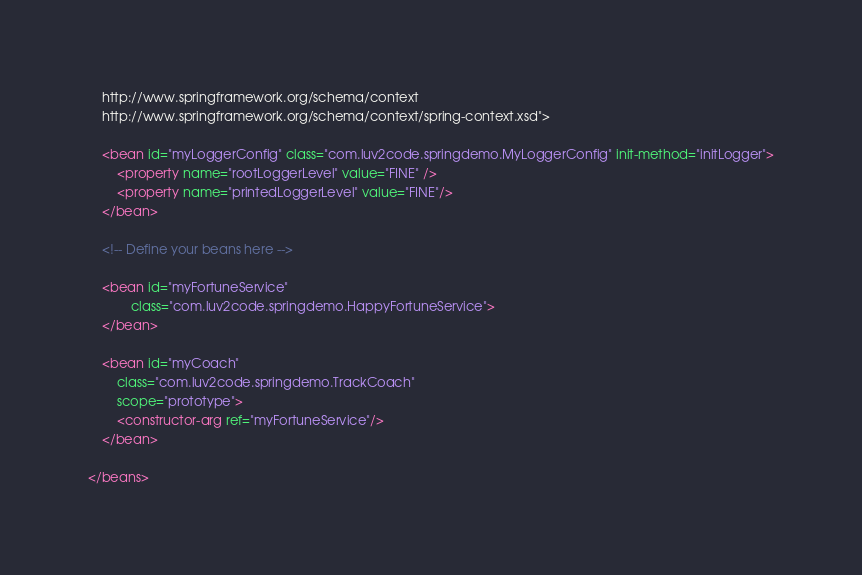<code> <loc_0><loc_0><loc_500><loc_500><_XML_>    http://www.springframework.org/schema/context
    http://www.springframework.org/schema/context/spring-context.xsd">

    <bean id="myLoggerConfig" class="com.luv2code.springdemo.MyLoggerConfig" init-method="initLogger">
    	<property name="rootLoggerLevel" value="FINE" />
    	<property name="printedLoggerLevel" value="FINE"/>
    </bean>
	
    <!-- Define your beans here -->
        
    <bean id="myFortuneService"
    		class="com.luv2code.springdemo.HappyFortuneService">
  	</bean>    

 	<bean id="myCoach"
 		class="com.luv2code.springdemo.TrackCoach"
 		scope="prototype">	
 		<constructor-arg ref="myFortuneService"/> 		
 	</bean>

</beans>





</code> 